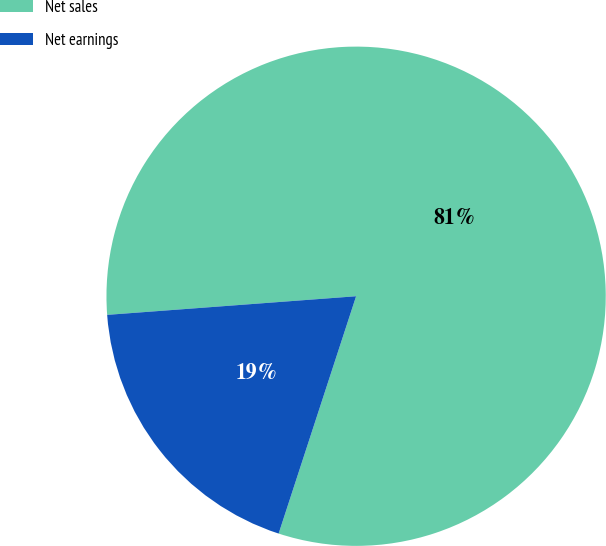Convert chart. <chart><loc_0><loc_0><loc_500><loc_500><pie_chart><fcel>Net sales<fcel>Net earnings<nl><fcel>81.21%<fcel>18.79%<nl></chart> 